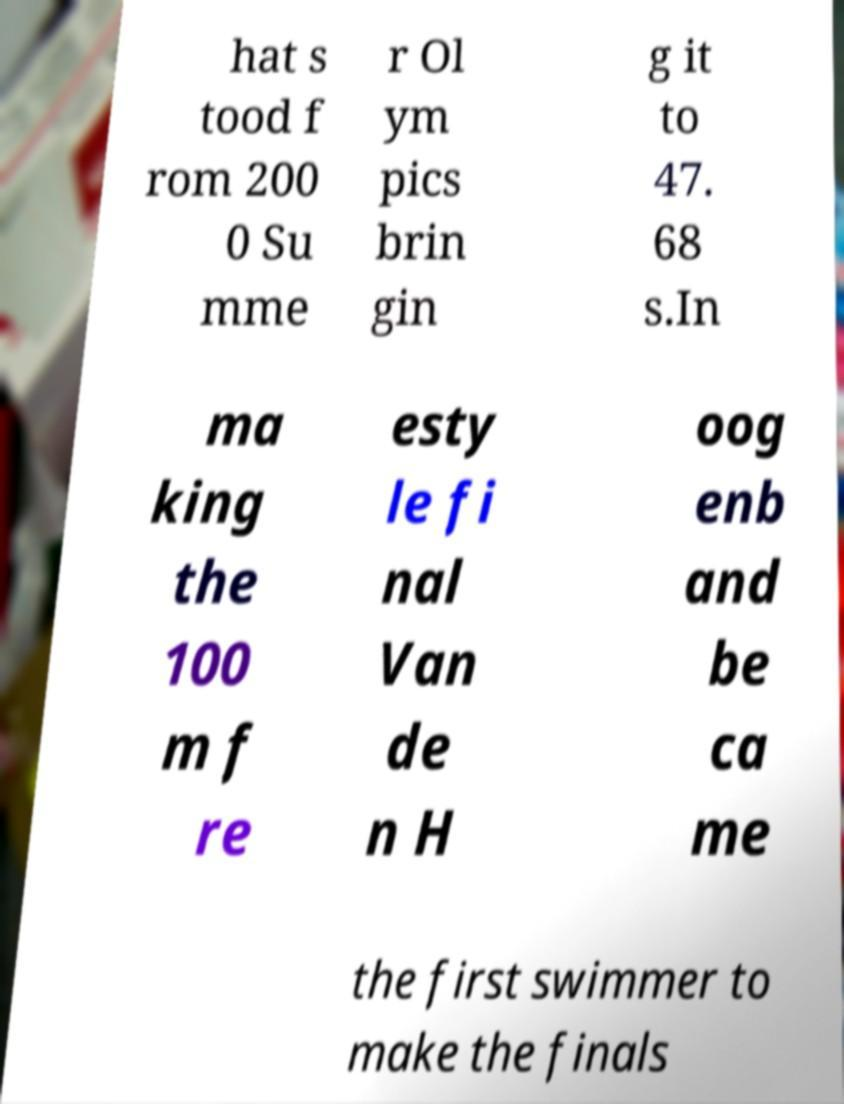Please identify and transcribe the text found in this image. hat s tood f rom 200 0 Su mme r Ol ym pics brin gin g it to 47. 68 s.In ma king the 100 m f re esty le fi nal Van de n H oog enb and be ca me the first swimmer to make the finals 